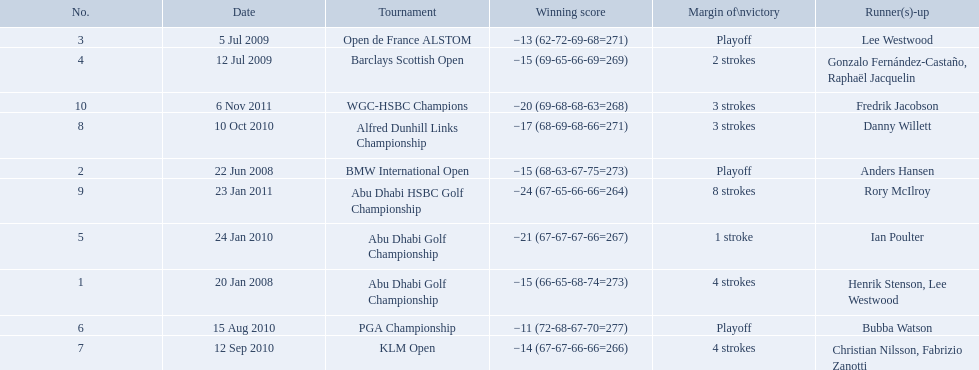Which tournaments did martin kaymer participate in? Abu Dhabi Golf Championship, BMW International Open, Open de France ALSTOM, Barclays Scottish Open, Abu Dhabi Golf Championship, PGA Championship, KLM Open, Alfred Dunhill Links Championship, Abu Dhabi HSBC Golf Championship, WGC-HSBC Champions. How many of these tournaments were won through a playoff? BMW International Open, Open de France ALSTOM, PGA Championship. Which of those tournaments took place in 2010? PGA Championship. Who had to top score next to martin kaymer for that tournament? Bubba Watson. 